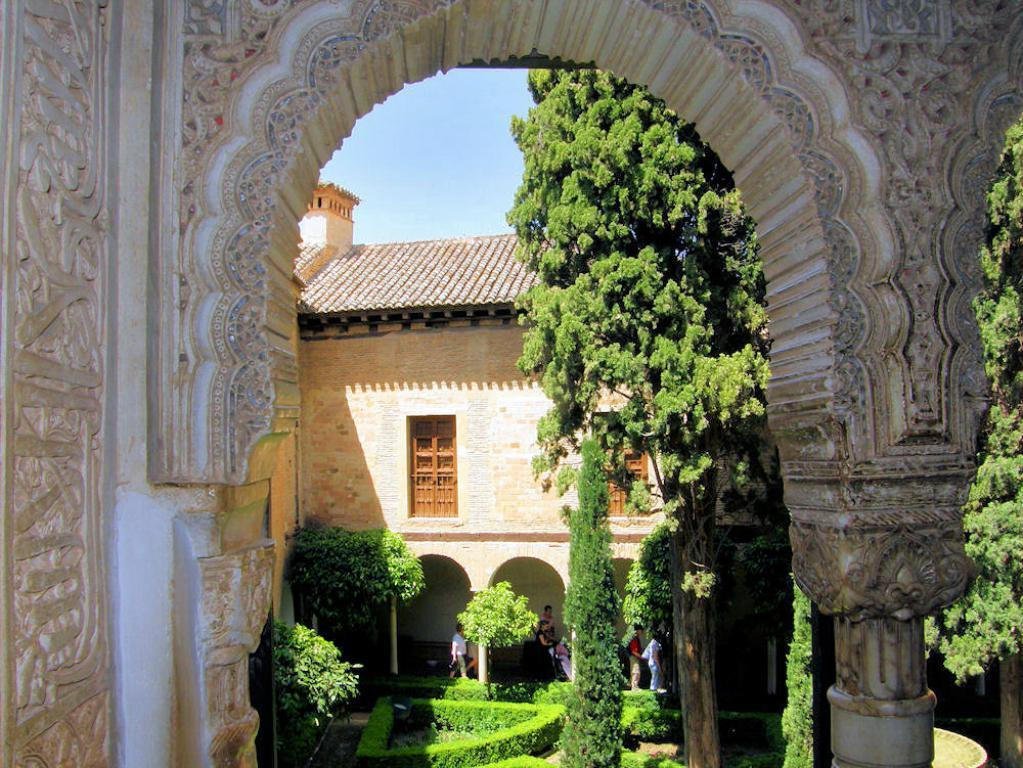What structure can be seen in the image? There is an arch in the image. What is located behind the arch? There are hedges, trees, a group of people, and a building behind the arch. What is visible behind the building? The sky is visible behind the building. What type of vest is being worn by the cook in the image? There is no cook or vest present in the image. Which type of berry can be seen growing on the trees in the image? There is no mention of berries or trees with berries in the image. 